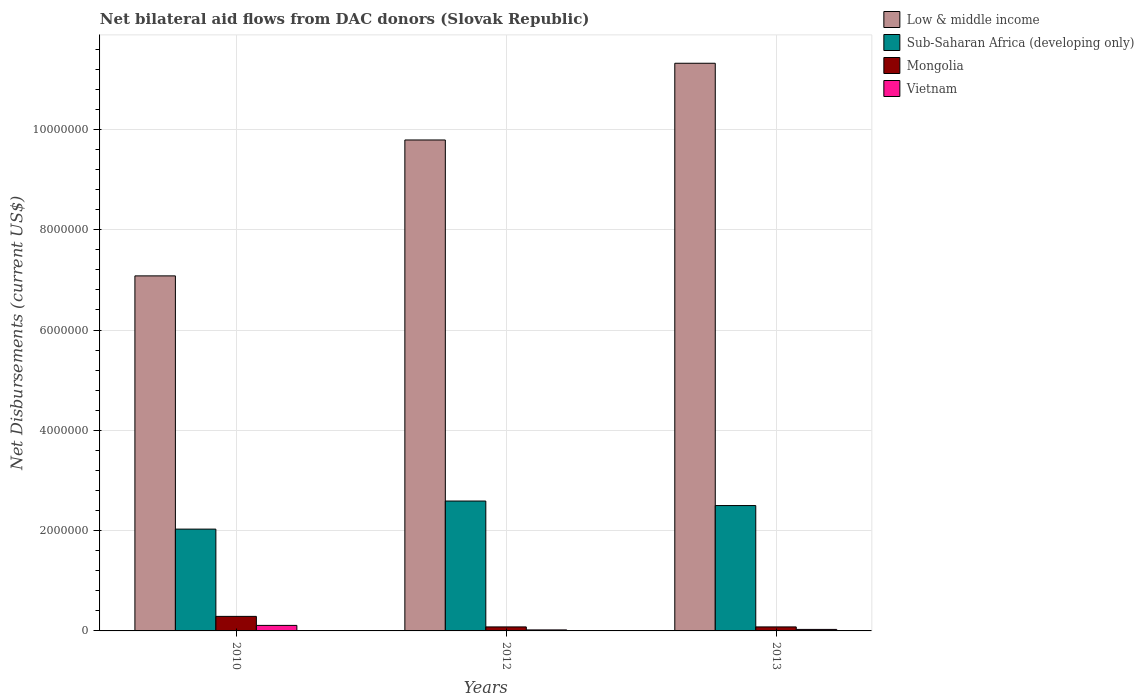How many groups of bars are there?
Ensure brevity in your answer.  3. Are the number of bars per tick equal to the number of legend labels?
Provide a succinct answer. Yes. In how many cases, is the number of bars for a given year not equal to the number of legend labels?
Keep it short and to the point. 0. What is the net bilateral aid flows in Vietnam in 2013?
Offer a very short reply. 3.00e+04. Across all years, what is the maximum net bilateral aid flows in Low & middle income?
Provide a succinct answer. 1.13e+07. Across all years, what is the minimum net bilateral aid flows in Vietnam?
Offer a terse response. 2.00e+04. In which year was the net bilateral aid flows in Mongolia minimum?
Provide a short and direct response. 2012. What is the total net bilateral aid flows in Vietnam in the graph?
Your answer should be compact. 1.60e+05. What is the difference between the net bilateral aid flows in Vietnam in 2010 and that in 2013?
Your response must be concise. 8.00e+04. What is the difference between the net bilateral aid flows in Sub-Saharan Africa (developing only) in 2012 and the net bilateral aid flows in Mongolia in 2013?
Your response must be concise. 2.51e+06. What is the average net bilateral aid flows in Sub-Saharan Africa (developing only) per year?
Your answer should be very brief. 2.37e+06. In the year 2010, what is the difference between the net bilateral aid flows in Vietnam and net bilateral aid flows in Mongolia?
Ensure brevity in your answer.  -1.80e+05. What is the ratio of the net bilateral aid flows in Sub-Saharan Africa (developing only) in 2010 to that in 2013?
Offer a very short reply. 0.81. What is the difference between the highest and the second highest net bilateral aid flows in Mongolia?
Provide a succinct answer. 2.10e+05. What is the difference between the highest and the lowest net bilateral aid flows in Low & middle income?
Your answer should be very brief. 4.24e+06. In how many years, is the net bilateral aid flows in Sub-Saharan Africa (developing only) greater than the average net bilateral aid flows in Sub-Saharan Africa (developing only) taken over all years?
Ensure brevity in your answer.  2. What does the 2nd bar from the left in 2010 represents?
Your answer should be compact. Sub-Saharan Africa (developing only). What does the 3rd bar from the right in 2012 represents?
Ensure brevity in your answer.  Sub-Saharan Africa (developing only). Is it the case that in every year, the sum of the net bilateral aid flows in Mongolia and net bilateral aid flows in Vietnam is greater than the net bilateral aid flows in Low & middle income?
Make the answer very short. No. How many years are there in the graph?
Your response must be concise. 3. What is the difference between two consecutive major ticks on the Y-axis?
Your answer should be compact. 2.00e+06. Are the values on the major ticks of Y-axis written in scientific E-notation?
Provide a succinct answer. No. Where does the legend appear in the graph?
Your response must be concise. Top right. How many legend labels are there?
Your answer should be very brief. 4. How are the legend labels stacked?
Make the answer very short. Vertical. What is the title of the graph?
Offer a terse response. Net bilateral aid flows from DAC donors (Slovak Republic). Does "Comoros" appear as one of the legend labels in the graph?
Your response must be concise. No. What is the label or title of the X-axis?
Ensure brevity in your answer.  Years. What is the label or title of the Y-axis?
Give a very brief answer. Net Disbursements (current US$). What is the Net Disbursements (current US$) in Low & middle income in 2010?
Offer a terse response. 7.08e+06. What is the Net Disbursements (current US$) in Sub-Saharan Africa (developing only) in 2010?
Offer a terse response. 2.03e+06. What is the Net Disbursements (current US$) of Mongolia in 2010?
Your answer should be compact. 2.90e+05. What is the Net Disbursements (current US$) of Low & middle income in 2012?
Provide a succinct answer. 9.79e+06. What is the Net Disbursements (current US$) in Sub-Saharan Africa (developing only) in 2012?
Your answer should be very brief. 2.59e+06. What is the Net Disbursements (current US$) in Mongolia in 2012?
Your response must be concise. 8.00e+04. What is the Net Disbursements (current US$) in Vietnam in 2012?
Provide a succinct answer. 2.00e+04. What is the Net Disbursements (current US$) in Low & middle income in 2013?
Offer a very short reply. 1.13e+07. What is the Net Disbursements (current US$) of Sub-Saharan Africa (developing only) in 2013?
Keep it short and to the point. 2.50e+06. Across all years, what is the maximum Net Disbursements (current US$) in Low & middle income?
Keep it short and to the point. 1.13e+07. Across all years, what is the maximum Net Disbursements (current US$) in Sub-Saharan Africa (developing only)?
Offer a terse response. 2.59e+06. Across all years, what is the maximum Net Disbursements (current US$) of Mongolia?
Offer a terse response. 2.90e+05. Across all years, what is the maximum Net Disbursements (current US$) in Vietnam?
Give a very brief answer. 1.10e+05. Across all years, what is the minimum Net Disbursements (current US$) in Low & middle income?
Give a very brief answer. 7.08e+06. Across all years, what is the minimum Net Disbursements (current US$) of Sub-Saharan Africa (developing only)?
Make the answer very short. 2.03e+06. Across all years, what is the minimum Net Disbursements (current US$) in Mongolia?
Your answer should be very brief. 8.00e+04. Across all years, what is the minimum Net Disbursements (current US$) of Vietnam?
Make the answer very short. 2.00e+04. What is the total Net Disbursements (current US$) in Low & middle income in the graph?
Ensure brevity in your answer.  2.82e+07. What is the total Net Disbursements (current US$) in Sub-Saharan Africa (developing only) in the graph?
Make the answer very short. 7.12e+06. What is the difference between the Net Disbursements (current US$) in Low & middle income in 2010 and that in 2012?
Your answer should be very brief. -2.71e+06. What is the difference between the Net Disbursements (current US$) in Sub-Saharan Africa (developing only) in 2010 and that in 2012?
Make the answer very short. -5.60e+05. What is the difference between the Net Disbursements (current US$) in Mongolia in 2010 and that in 2012?
Provide a short and direct response. 2.10e+05. What is the difference between the Net Disbursements (current US$) in Vietnam in 2010 and that in 2012?
Provide a succinct answer. 9.00e+04. What is the difference between the Net Disbursements (current US$) in Low & middle income in 2010 and that in 2013?
Make the answer very short. -4.24e+06. What is the difference between the Net Disbursements (current US$) in Sub-Saharan Africa (developing only) in 2010 and that in 2013?
Offer a terse response. -4.70e+05. What is the difference between the Net Disbursements (current US$) in Vietnam in 2010 and that in 2013?
Give a very brief answer. 8.00e+04. What is the difference between the Net Disbursements (current US$) of Low & middle income in 2012 and that in 2013?
Make the answer very short. -1.53e+06. What is the difference between the Net Disbursements (current US$) in Mongolia in 2012 and that in 2013?
Ensure brevity in your answer.  0. What is the difference between the Net Disbursements (current US$) of Low & middle income in 2010 and the Net Disbursements (current US$) of Sub-Saharan Africa (developing only) in 2012?
Your answer should be compact. 4.49e+06. What is the difference between the Net Disbursements (current US$) of Low & middle income in 2010 and the Net Disbursements (current US$) of Vietnam in 2012?
Make the answer very short. 7.06e+06. What is the difference between the Net Disbursements (current US$) in Sub-Saharan Africa (developing only) in 2010 and the Net Disbursements (current US$) in Mongolia in 2012?
Your answer should be compact. 1.95e+06. What is the difference between the Net Disbursements (current US$) of Sub-Saharan Africa (developing only) in 2010 and the Net Disbursements (current US$) of Vietnam in 2012?
Your answer should be very brief. 2.01e+06. What is the difference between the Net Disbursements (current US$) of Low & middle income in 2010 and the Net Disbursements (current US$) of Sub-Saharan Africa (developing only) in 2013?
Ensure brevity in your answer.  4.58e+06. What is the difference between the Net Disbursements (current US$) of Low & middle income in 2010 and the Net Disbursements (current US$) of Vietnam in 2013?
Provide a succinct answer. 7.05e+06. What is the difference between the Net Disbursements (current US$) in Sub-Saharan Africa (developing only) in 2010 and the Net Disbursements (current US$) in Mongolia in 2013?
Your answer should be compact. 1.95e+06. What is the difference between the Net Disbursements (current US$) of Mongolia in 2010 and the Net Disbursements (current US$) of Vietnam in 2013?
Your response must be concise. 2.60e+05. What is the difference between the Net Disbursements (current US$) of Low & middle income in 2012 and the Net Disbursements (current US$) of Sub-Saharan Africa (developing only) in 2013?
Your answer should be very brief. 7.29e+06. What is the difference between the Net Disbursements (current US$) of Low & middle income in 2012 and the Net Disbursements (current US$) of Mongolia in 2013?
Provide a succinct answer. 9.71e+06. What is the difference between the Net Disbursements (current US$) of Low & middle income in 2012 and the Net Disbursements (current US$) of Vietnam in 2013?
Your answer should be compact. 9.76e+06. What is the difference between the Net Disbursements (current US$) of Sub-Saharan Africa (developing only) in 2012 and the Net Disbursements (current US$) of Mongolia in 2013?
Give a very brief answer. 2.51e+06. What is the difference between the Net Disbursements (current US$) in Sub-Saharan Africa (developing only) in 2012 and the Net Disbursements (current US$) in Vietnam in 2013?
Your answer should be very brief. 2.56e+06. What is the difference between the Net Disbursements (current US$) of Mongolia in 2012 and the Net Disbursements (current US$) of Vietnam in 2013?
Keep it short and to the point. 5.00e+04. What is the average Net Disbursements (current US$) in Low & middle income per year?
Provide a short and direct response. 9.40e+06. What is the average Net Disbursements (current US$) of Sub-Saharan Africa (developing only) per year?
Keep it short and to the point. 2.37e+06. What is the average Net Disbursements (current US$) of Vietnam per year?
Provide a succinct answer. 5.33e+04. In the year 2010, what is the difference between the Net Disbursements (current US$) in Low & middle income and Net Disbursements (current US$) in Sub-Saharan Africa (developing only)?
Offer a terse response. 5.05e+06. In the year 2010, what is the difference between the Net Disbursements (current US$) in Low & middle income and Net Disbursements (current US$) in Mongolia?
Your answer should be compact. 6.79e+06. In the year 2010, what is the difference between the Net Disbursements (current US$) in Low & middle income and Net Disbursements (current US$) in Vietnam?
Keep it short and to the point. 6.97e+06. In the year 2010, what is the difference between the Net Disbursements (current US$) in Sub-Saharan Africa (developing only) and Net Disbursements (current US$) in Mongolia?
Provide a succinct answer. 1.74e+06. In the year 2010, what is the difference between the Net Disbursements (current US$) in Sub-Saharan Africa (developing only) and Net Disbursements (current US$) in Vietnam?
Offer a terse response. 1.92e+06. In the year 2012, what is the difference between the Net Disbursements (current US$) of Low & middle income and Net Disbursements (current US$) of Sub-Saharan Africa (developing only)?
Provide a short and direct response. 7.20e+06. In the year 2012, what is the difference between the Net Disbursements (current US$) of Low & middle income and Net Disbursements (current US$) of Mongolia?
Your answer should be very brief. 9.71e+06. In the year 2012, what is the difference between the Net Disbursements (current US$) in Low & middle income and Net Disbursements (current US$) in Vietnam?
Give a very brief answer. 9.77e+06. In the year 2012, what is the difference between the Net Disbursements (current US$) of Sub-Saharan Africa (developing only) and Net Disbursements (current US$) of Mongolia?
Provide a succinct answer. 2.51e+06. In the year 2012, what is the difference between the Net Disbursements (current US$) of Sub-Saharan Africa (developing only) and Net Disbursements (current US$) of Vietnam?
Provide a short and direct response. 2.57e+06. In the year 2013, what is the difference between the Net Disbursements (current US$) of Low & middle income and Net Disbursements (current US$) of Sub-Saharan Africa (developing only)?
Provide a succinct answer. 8.82e+06. In the year 2013, what is the difference between the Net Disbursements (current US$) of Low & middle income and Net Disbursements (current US$) of Mongolia?
Make the answer very short. 1.12e+07. In the year 2013, what is the difference between the Net Disbursements (current US$) of Low & middle income and Net Disbursements (current US$) of Vietnam?
Offer a terse response. 1.13e+07. In the year 2013, what is the difference between the Net Disbursements (current US$) of Sub-Saharan Africa (developing only) and Net Disbursements (current US$) of Mongolia?
Your response must be concise. 2.42e+06. In the year 2013, what is the difference between the Net Disbursements (current US$) in Sub-Saharan Africa (developing only) and Net Disbursements (current US$) in Vietnam?
Your answer should be very brief. 2.47e+06. In the year 2013, what is the difference between the Net Disbursements (current US$) in Mongolia and Net Disbursements (current US$) in Vietnam?
Provide a succinct answer. 5.00e+04. What is the ratio of the Net Disbursements (current US$) of Low & middle income in 2010 to that in 2012?
Provide a short and direct response. 0.72. What is the ratio of the Net Disbursements (current US$) in Sub-Saharan Africa (developing only) in 2010 to that in 2012?
Offer a very short reply. 0.78. What is the ratio of the Net Disbursements (current US$) in Mongolia in 2010 to that in 2012?
Give a very brief answer. 3.62. What is the ratio of the Net Disbursements (current US$) in Low & middle income in 2010 to that in 2013?
Keep it short and to the point. 0.63. What is the ratio of the Net Disbursements (current US$) of Sub-Saharan Africa (developing only) in 2010 to that in 2013?
Offer a very short reply. 0.81. What is the ratio of the Net Disbursements (current US$) in Mongolia in 2010 to that in 2013?
Provide a short and direct response. 3.62. What is the ratio of the Net Disbursements (current US$) of Vietnam in 2010 to that in 2013?
Provide a short and direct response. 3.67. What is the ratio of the Net Disbursements (current US$) of Low & middle income in 2012 to that in 2013?
Offer a very short reply. 0.86. What is the ratio of the Net Disbursements (current US$) in Sub-Saharan Africa (developing only) in 2012 to that in 2013?
Ensure brevity in your answer.  1.04. What is the ratio of the Net Disbursements (current US$) of Mongolia in 2012 to that in 2013?
Keep it short and to the point. 1. What is the difference between the highest and the second highest Net Disbursements (current US$) of Low & middle income?
Ensure brevity in your answer.  1.53e+06. What is the difference between the highest and the second highest Net Disbursements (current US$) in Mongolia?
Your answer should be very brief. 2.10e+05. What is the difference between the highest and the second highest Net Disbursements (current US$) in Vietnam?
Offer a terse response. 8.00e+04. What is the difference between the highest and the lowest Net Disbursements (current US$) in Low & middle income?
Your answer should be very brief. 4.24e+06. What is the difference between the highest and the lowest Net Disbursements (current US$) in Sub-Saharan Africa (developing only)?
Your answer should be compact. 5.60e+05. What is the difference between the highest and the lowest Net Disbursements (current US$) of Mongolia?
Keep it short and to the point. 2.10e+05. 